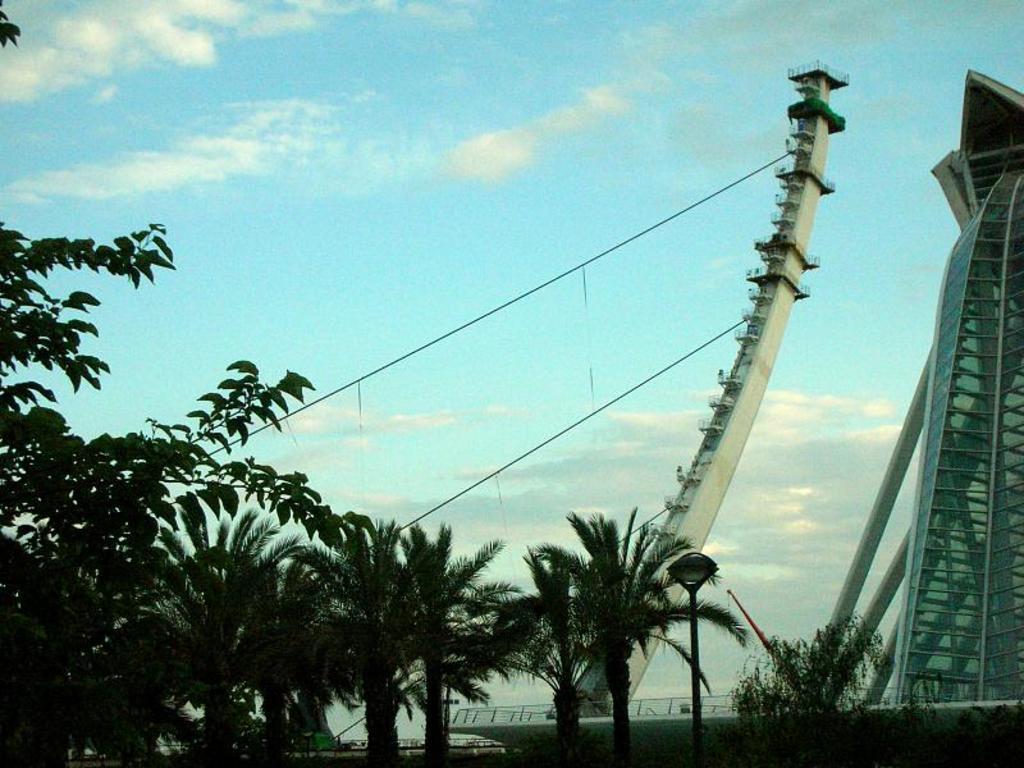Could you give a brief overview of what you see in this image? In this image we can see few buildings. There are many trees in the image. We can see few cables. We can see the clouds in the sky. 